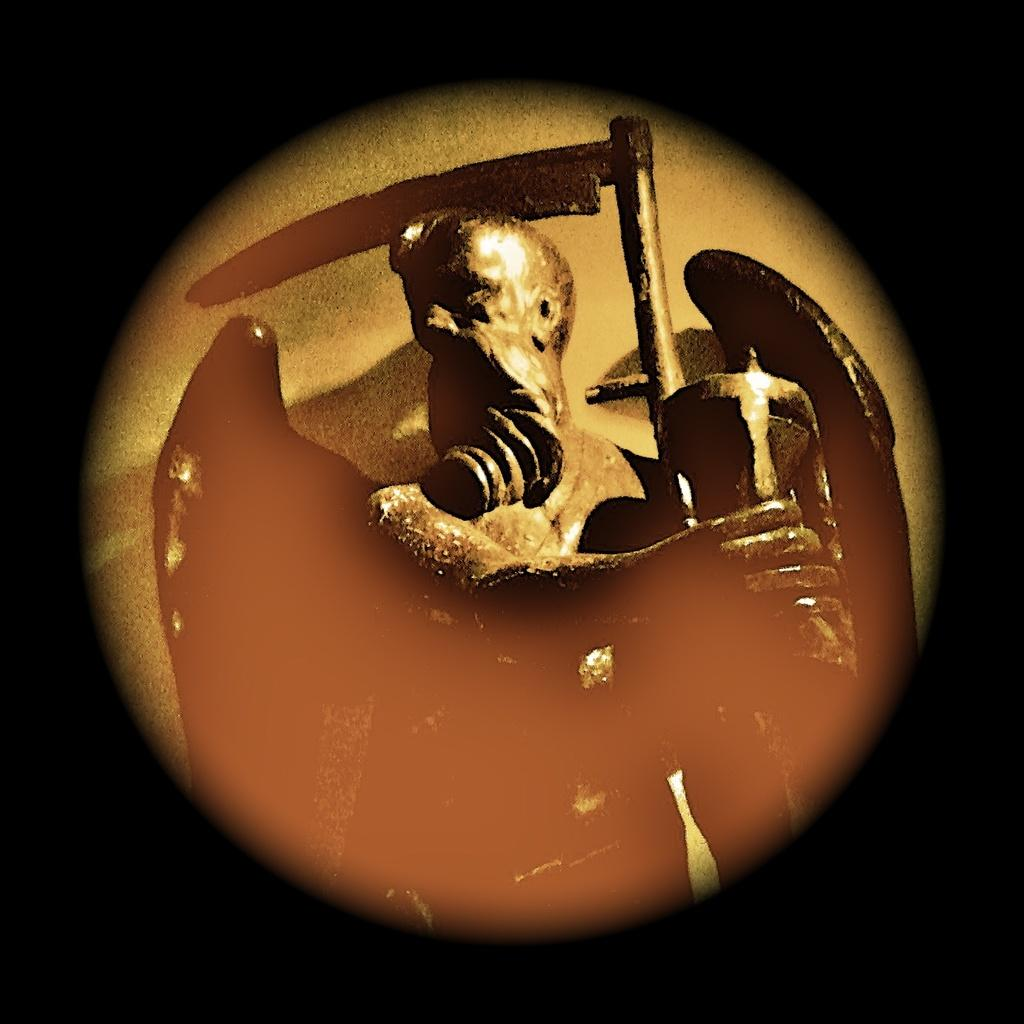What is the main subject of the image? The main subject of the image is a painting. What does the painting depict? The painting depicts a sculpture. What is the sculpture of? The sculpture is of a man. What is the man holding in the sculpture? The man is holding a weapon. What additional feature does the man have in the sculpture? The man has wings. Can you tell me how many plates are stacked on the frog in the image? There are no plates or frogs present in the image. What type of creature is shown hiding behind the bushes in the image? There is no creature or bushes present in the image. 